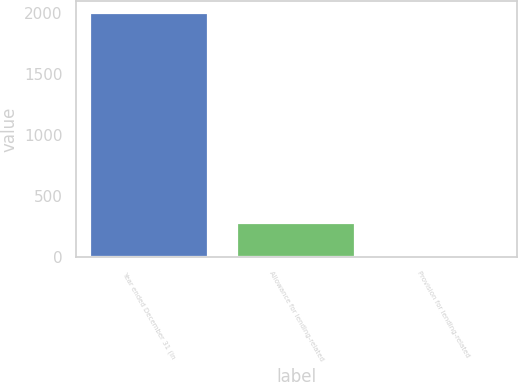<chart> <loc_0><loc_0><loc_500><loc_500><bar_chart><fcel>Year ended December 31 (in<fcel>Allowance for lending-related<fcel>Provision for lending-related<nl><fcel>2001<fcel>282<fcel>3<nl></chart> 